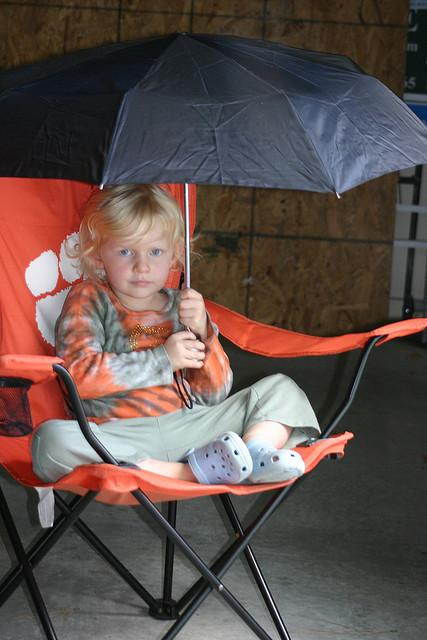What minimalizing action can this chair be made to do? Please explain your reasoning. fold up. It is a portable chair 